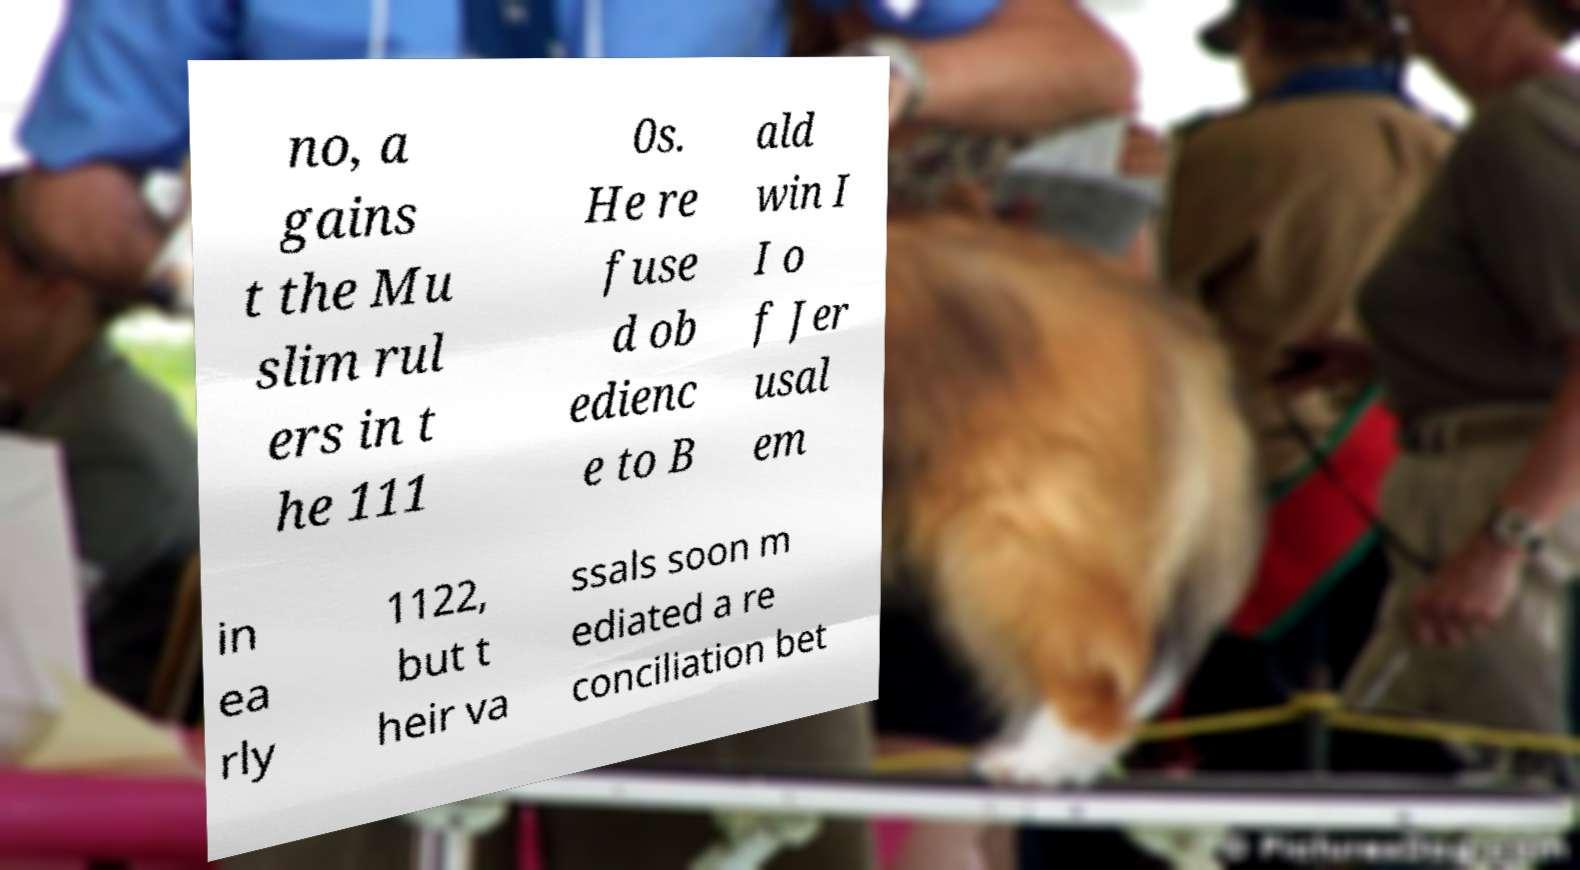For documentation purposes, I need the text within this image transcribed. Could you provide that? no, a gains t the Mu slim rul ers in t he 111 0s. He re fuse d ob edienc e to B ald win I I o f Jer usal em in ea rly 1122, but t heir va ssals soon m ediated a re conciliation bet 